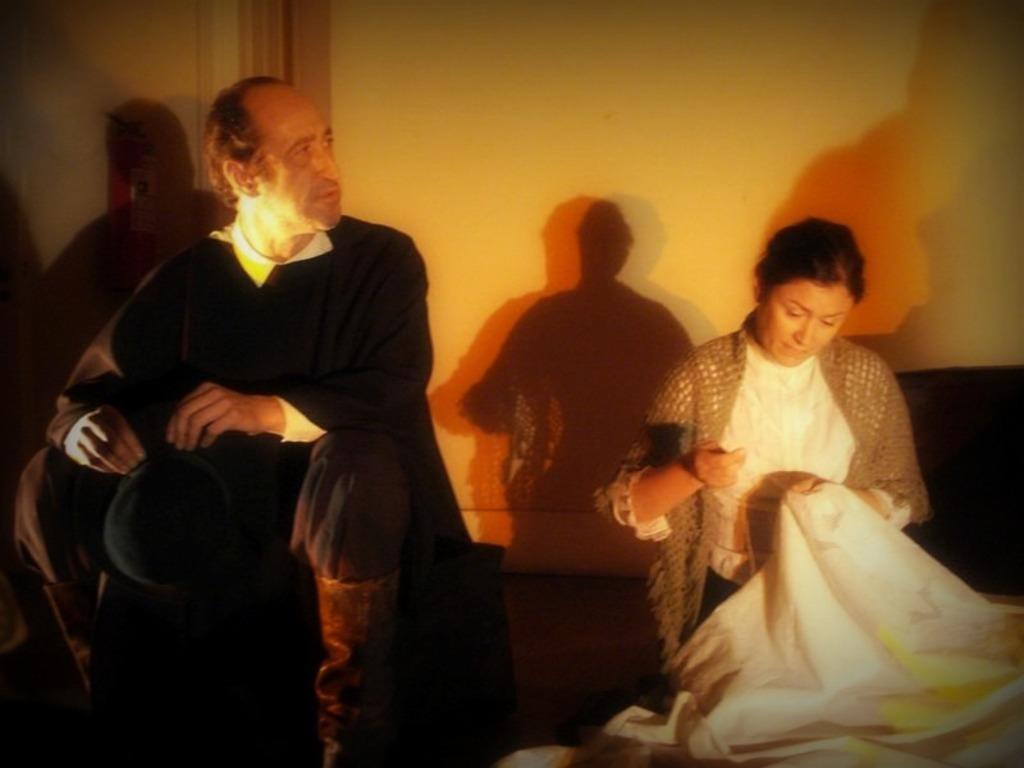Could you give a brief overview of what you see in this image? In this image, on the left side, we can see a man sitting, on the right side there is a woman holding a cloth, in the background, we can see the wall and we can see the shadow of a man on the wall. 